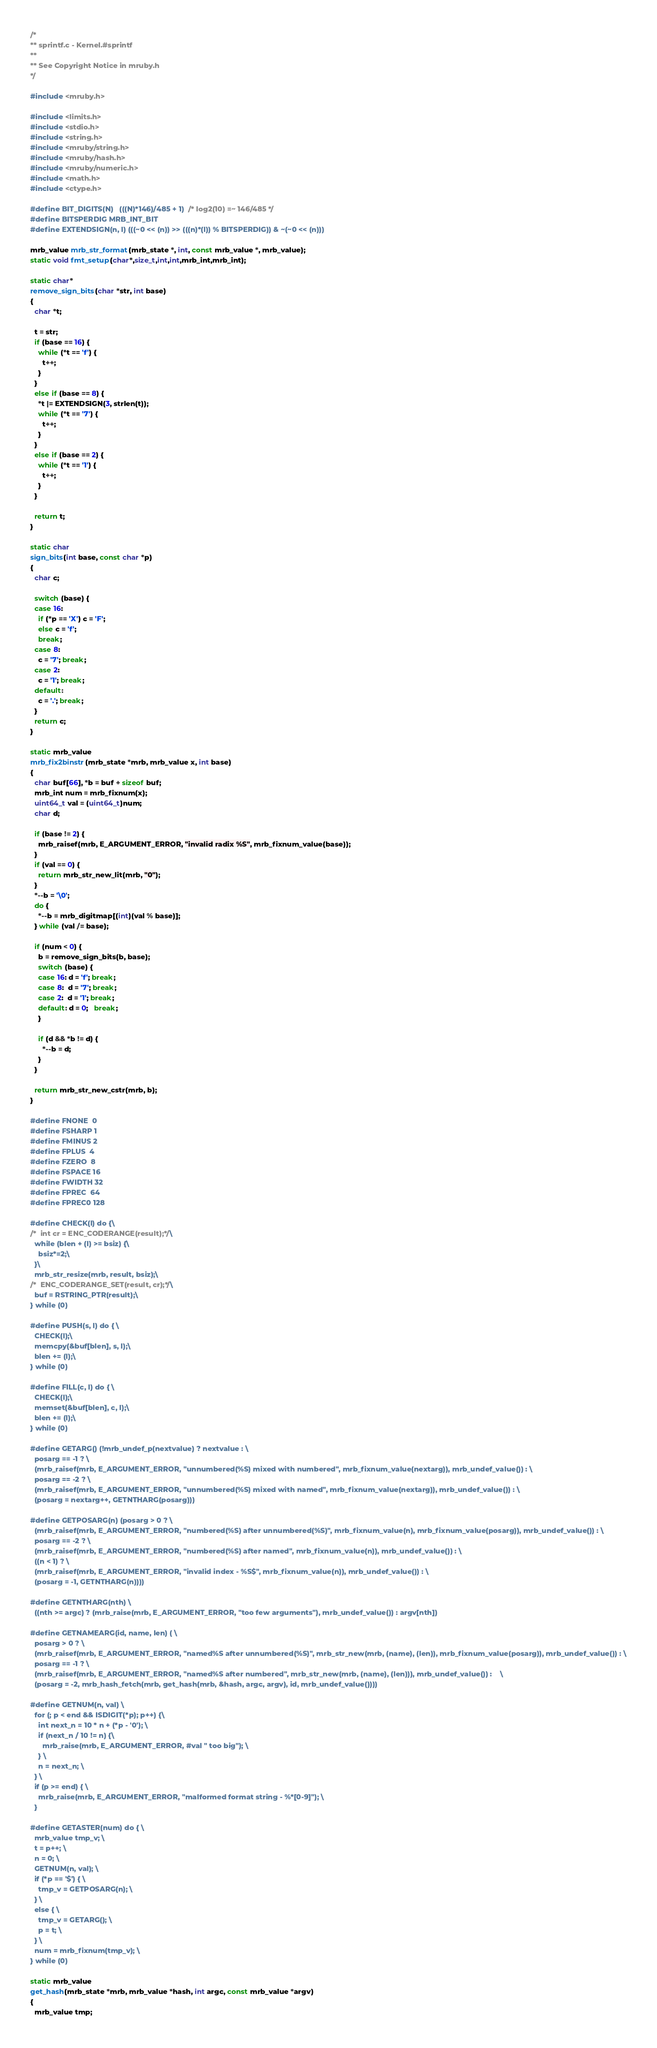Convert code to text. <code><loc_0><loc_0><loc_500><loc_500><_C_>/*
** sprintf.c - Kernel.#sprintf
**
** See Copyright Notice in mruby.h
*/

#include <mruby.h>

#include <limits.h>
#include <stdio.h>
#include <string.h>
#include <mruby/string.h>
#include <mruby/hash.h>
#include <mruby/numeric.h>
#include <math.h>
#include <ctype.h>

#define BIT_DIGITS(N)   (((N)*146)/485 + 1)  /* log2(10) =~ 146/485 */
#define BITSPERDIG MRB_INT_BIT
#define EXTENDSIGN(n, l) (((~0 << (n)) >> (((n)*(l)) % BITSPERDIG)) & ~(~0 << (n)))

mrb_value mrb_str_format(mrb_state *, int, const mrb_value *, mrb_value);
static void fmt_setup(char*,size_t,int,int,mrb_int,mrb_int);

static char*
remove_sign_bits(char *str, int base)
{
  char *t;

  t = str;
  if (base == 16) {
    while (*t == 'f') {
      t++;
    }
  }
  else if (base == 8) {
    *t |= EXTENDSIGN(3, strlen(t));
    while (*t == '7') {
      t++;
    }
  }
  else if (base == 2) {
    while (*t == '1') {
      t++;
    }
  }

  return t;
}

static char
sign_bits(int base, const char *p)
{
  char c;

  switch (base) {
  case 16:
    if (*p == 'X') c = 'F';
    else c = 'f';
    break;
  case 8:
    c = '7'; break;
  case 2:
    c = '1'; break;
  default:
    c = '.'; break;
  }
  return c;
}

static mrb_value
mrb_fix2binstr(mrb_state *mrb, mrb_value x, int base)
{
  char buf[66], *b = buf + sizeof buf;
  mrb_int num = mrb_fixnum(x);
  uint64_t val = (uint64_t)num;
  char d;

  if (base != 2) {
    mrb_raisef(mrb, E_ARGUMENT_ERROR, "invalid radix %S", mrb_fixnum_value(base));
  }
  if (val == 0) {
    return mrb_str_new_lit(mrb, "0");
  }
  *--b = '\0';
  do {
    *--b = mrb_digitmap[(int)(val % base)];
  } while (val /= base);

  if (num < 0) {
    b = remove_sign_bits(b, base);
    switch (base) {
    case 16: d = 'f'; break;
    case 8:  d = '7'; break;
    case 2:  d = '1'; break;
    default: d = 0;   break;
    }

    if (d && *b != d) {
      *--b = d;
    }
  }

  return mrb_str_new_cstr(mrb, b);
}

#define FNONE  0
#define FSHARP 1
#define FMINUS 2
#define FPLUS  4
#define FZERO  8
#define FSPACE 16
#define FWIDTH 32
#define FPREC  64
#define FPREC0 128

#define CHECK(l) do {\
/*  int cr = ENC_CODERANGE(result);*/\
  while (blen + (l) >= bsiz) {\
    bsiz*=2;\
  }\
  mrb_str_resize(mrb, result, bsiz);\
/*  ENC_CODERANGE_SET(result, cr);*/\
  buf = RSTRING_PTR(result);\
} while (0)

#define PUSH(s, l) do { \
  CHECK(l);\
  memcpy(&buf[blen], s, l);\
  blen += (l);\
} while (0)

#define FILL(c, l) do { \
  CHECK(l);\
  memset(&buf[blen], c, l);\
  blen += (l);\
} while (0)

#define GETARG() (!mrb_undef_p(nextvalue) ? nextvalue : \
  posarg == -1 ? \
  (mrb_raisef(mrb, E_ARGUMENT_ERROR, "unnumbered(%S) mixed with numbered", mrb_fixnum_value(nextarg)), mrb_undef_value()) : \
  posarg == -2 ? \
  (mrb_raisef(mrb, E_ARGUMENT_ERROR, "unnumbered(%S) mixed with named", mrb_fixnum_value(nextarg)), mrb_undef_value()) : \
  (posarg = nextarg++, GETNTHARG(posarg)))

#define GETPOSARG(n) (posarg > 0 ? \
  (mrb_raisef(mrb, E_ARGUMENT_ERROR, "numbered(%S) after unnumbered(%S)", mrb_fixnum_value(n), mrb_fixnum_value(posarg)), mrb_undef_value()) : \
  posarg == -2 ? \
  (mrb_raisef(mrb, E_ARGUMENT_ERROR, "numbered(%S) after named", mrb_fixnum_value(n)), mrb_undef_value()) : \
  ((n < 1) ? \
  (mrb_raisef(mrb, E_ARGUMENT_ERROR, "invalid index - %S$", mrb_fixnum_value(n)), mrb_undef_value()) : \
  (posarg = -1, GETNTHARG(n))))

#define GETNTHARG(nth) \
  ((nth >= argc) ? (mrb_raise(mrb, E_ARGUMENT_ERROR, "too few arguments"), mrb_undef_value()) : argv[nth])

#define GETNAMEARG(id, name, len) ( \
  posarg > 0 ? \
  (mrb_raisef(mrb, E_ARGUMENT_ERROR, "named%S after unnumbered(%S)", mrb_str_new(mrb, (name), (len)), mrb_fixnum_value(posarg)), mrb_undef_value()) : \
  posarg == -1 ? \
  (mrb_raisef(mrb, E_ARGUMENT_ERROR, "named%S after numbered", mrb_str_new(mrb, (name), (len))), mrb_undef_value()) :    \
  (posarg = -2, mrb_hash_fetch(mrb, get_hash(mrb, &hash, argc, argv), id, mrb_undef_value())))

#define GETNUM(n, val) \
  for (; p < end && ISDIGIT(*p); p++) {\
    int next_n = 10 * n + (*p - '0'); \
    if (next_n / 10 != n) {\
      mrb_raise(mrb, E_ARGUMENT_ERROR, #val " too big"); \
    } \
    n = next_n; \
  } \
  if (p >= end) { \
    mrb_raise(mrb, E_ARGUMENT_ERROR, "malformed format string - %*[0-9]"); \
  }

#define GETASTER(num) do { \
  mrb_value tmp_v; \
  t = p++; \
  n = 0; \
  GETNUM(n, val); \
  if (*p == '$') { \
    tmp_v = GETPOSARG(n); \
  } \
  else { \
    tmp_v = GETARG(); \
    p = t; \
  } \
  num = mrb_fixnum(tmp_v); \
} while (0)

static mrb_value
get_hash(mrb_state *mrb, mrb_value *hash, int argc, const mrb_value *argv)
{
  mrb_value tmp;
</code> 